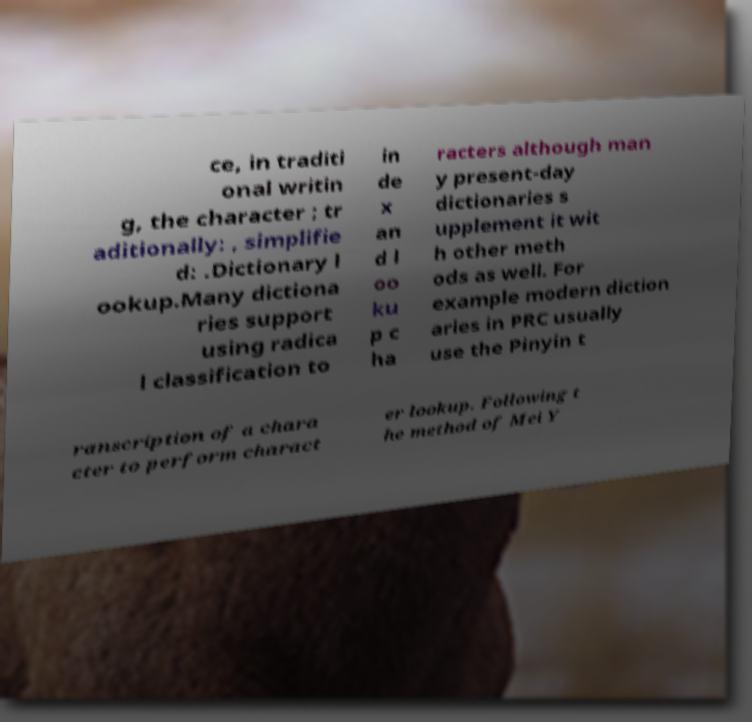Could you extract and type out the text from this image? ce, in traditi onal writin g, the character ; tr aditionally: , simplifie d: .Dictionary l ookup.Many dictiona ries support using radica l classification to in de x an d l oo ku p c ha racters although man y present-day dictionaries s upplement it wit h other meth ods as well. For example modern diction aries in PRC usually use the Pinyin t ranscription of a chara cter to perform charact er lookup. Following t he method of Mei Y 